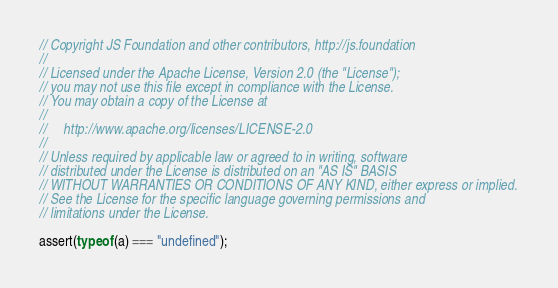Convert code to text. <code><loc_0><loc_0><loc_500><loc_500><_JavaScript_>// Copyright JS Foundation and other contributors, http://js.foundation
//
// Licensed under the Apache License, Version 2.0 (the "License");
// you may not use this file except in compliance with the License.
// You may obtain a copy of the License at
//
//     http://www.apache.org/licenses/LICENSE-2.0
//
// Unless required by applicable law or agreed to in writing, software
// distributed under the License is distributed on an "AS IS" BASIS
// WITHOUT WARRANTIES OR CONDITIONS OF ANY KIND, either express or implied.
// See the License for the specific language governing permissions and
// limitations under the License.

assert(typeof (a) === "undefined");
</code> 